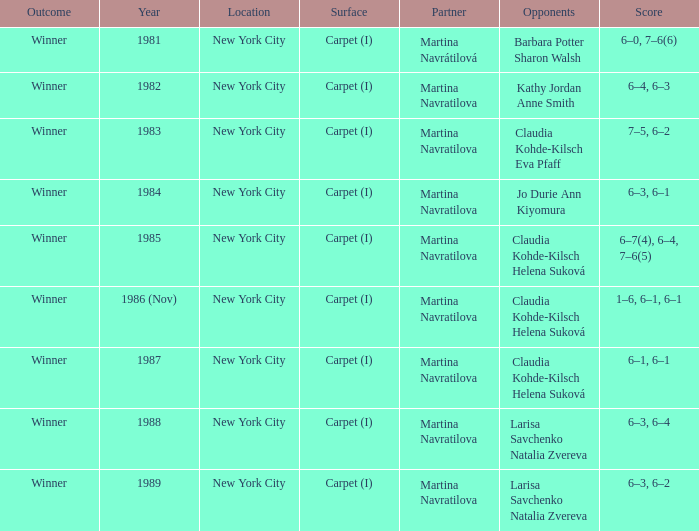How many partners were there in 1988? 1.0. Could you parse the entire table? {'header': ['Outcome', 'Year', 'Location', 'Surface', 'Partner', 'Opponents', 'Score'], 'rows': [['Winner', '1981', 'New York City', 'Carpet (I)', 'Martina Navrátilová', 'Barbara Potter Sharon Walsh', '6–0, 7–6(6)'], ['Winner', '1982', 'New York City', 'Carpet (I)', 'Martina Navratilova', 'Kathy Jordan Anne Smith', '6–4, 6–3'], ['Winner', '1983', 'New York City', 'Carpet (I)', 'Martina Navratilova', 'Claudia Kohde-Kilsch Eva Pfaff', '7–5, 6–2'], ['Winner', '1984', 'New York City', 'Carpet (I)', 'Martina Navratilova', 'Jo Durie Ann Kiyomura', '6–3, 6–1'], ['Winner', '1985', 'New York City', 'Carpet (I)', 'Martina Navratilova', 'Claudia Kohde-Kilsch Helena Suková', '6–7(4), 6–4, 7–6(5)'], ['Winner', '1986 (Nov)', 'New York City', 'Carpet (I)', 'Martina Navratilova', 'Claudia Kohde-Kilsch Helena Suková', '1–6, 6–1, 6–1'], ['Winner', '1987', 'New York City', 'Carpet (I)', 'Martina Navratilova', 'Claudia Kohde-Kilsch Helena Suková', '6–1, 6–1'], ['Winner', '1988', 'New York City', 'Carpet (I)', 'Martina Navratilova', 'Larisa Savchenko Natalia Zvereva', '6–3, 6–4'], ['Winner', '1989', 'New York City', 'Carpet (I)', 'Martina Navratilova', 'Larisa Savchenko Natalia Zvereva', '6–3, 6–2']]} 